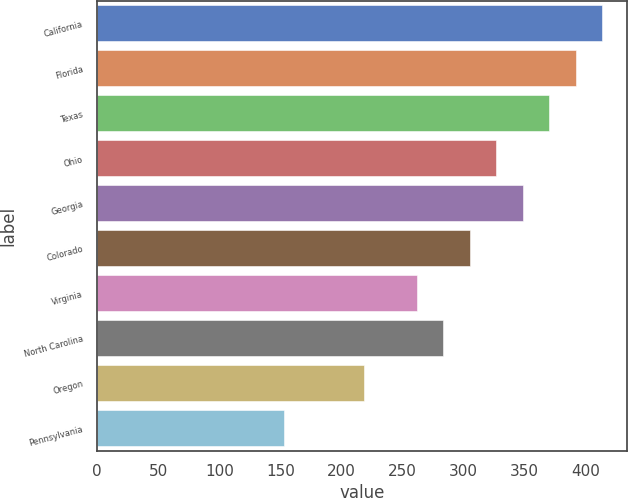Convert chart. <chart><loc_0><loc_0><loc_500><loc_500><bar_chart><fcel>California<fcel>Florida<fcel>Texas<fcel>Ohio<fcel>Georgia<fcel>Colorado<fcel>Virginia<fcel>North Carolina<fcel>Oregon<fcel>Pennsylvania<nl><fcel>413.3<fcel>391.6<fcel>369.9<fcel>326.5<fcel>348.2<fcel>304.8<fcel>261.4<fcel>283.1<fcel>218<fcel>152.9<nl></chart> 